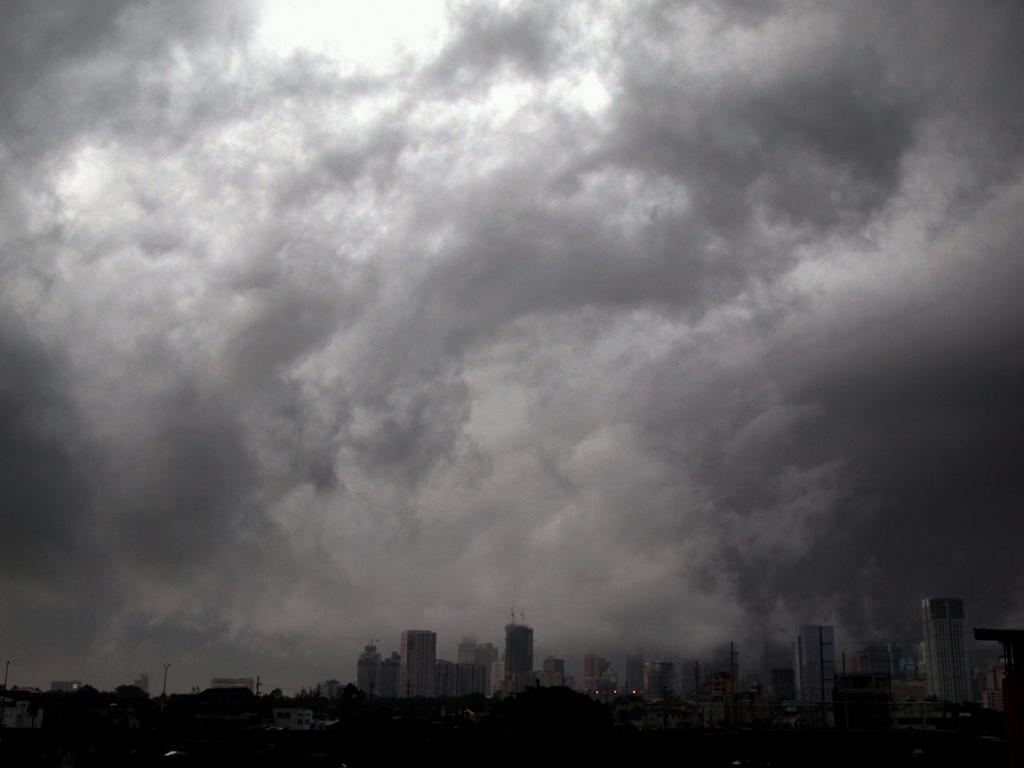What type of structures can be seen in the image? There are buildings in the image. What can be seen in the sky in the image? There are clouds visible in the image. What is the color scheme of the image? The image is a black and white photography. What type of alarm can be heard going off in the image? There is no alarm present in the image, as it is a still photograph. Can you tell me who the main character is in the joke that is being told in the image? There is no joke being told in the image, as it is a photograph of buildings and clouds. 